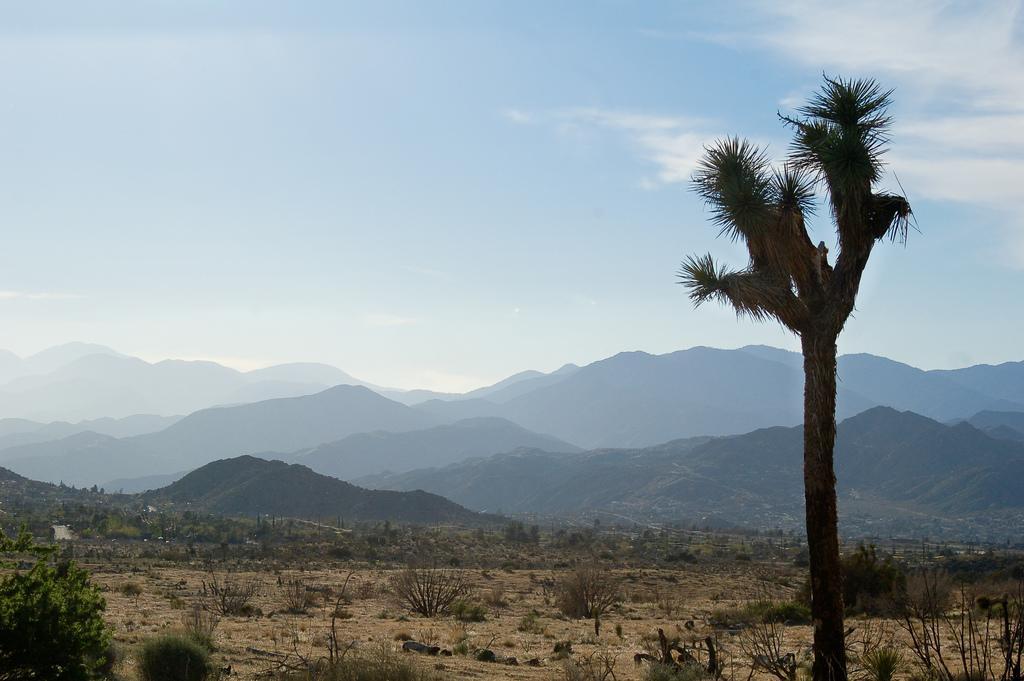Please provide a concise description of this image. In this image I can see few trees,small plants and few mountains. The sky is in white and blue color. 